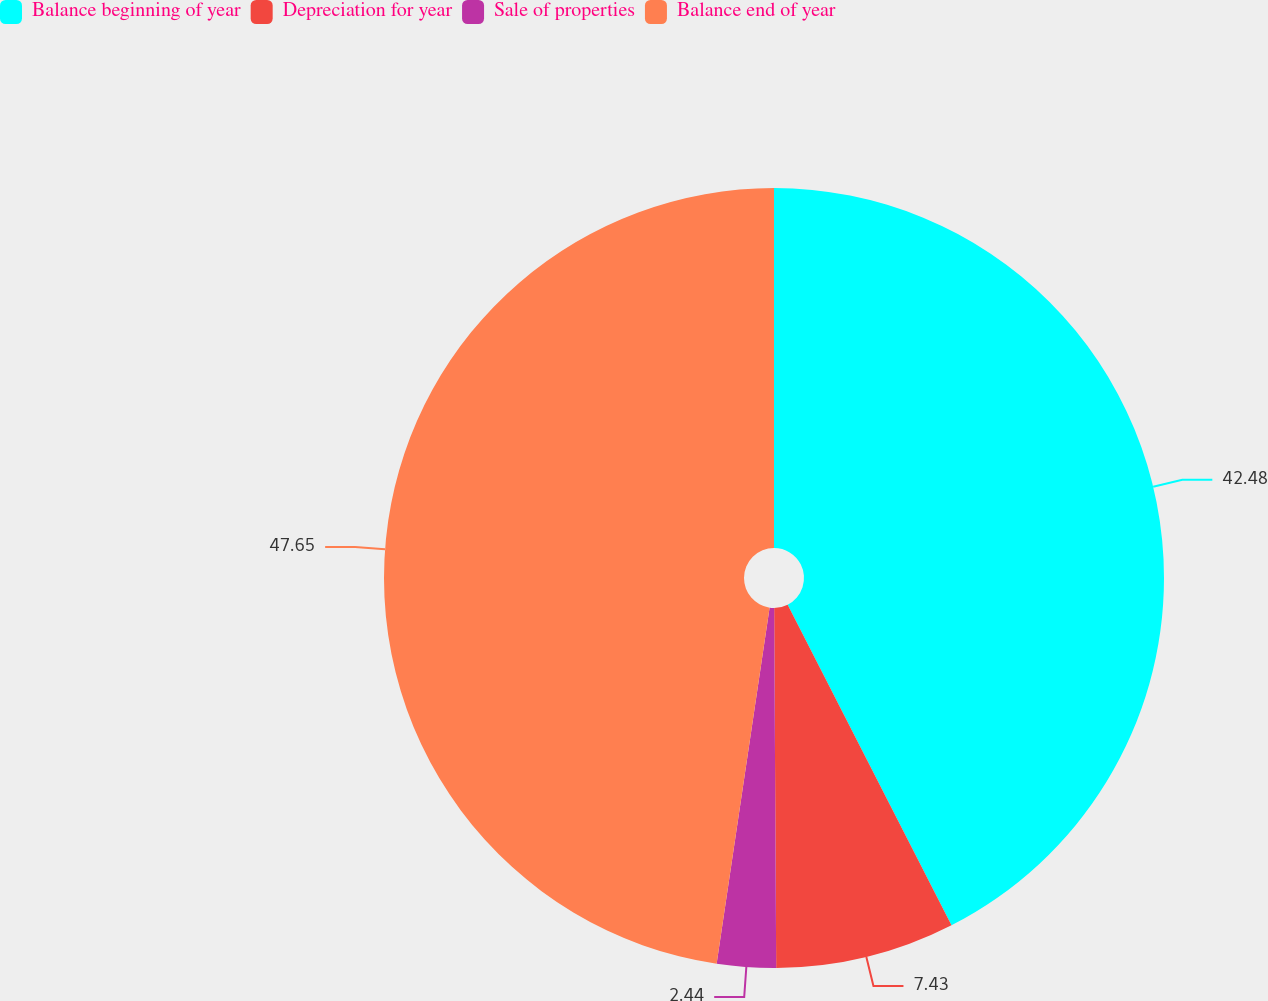Convert chart to OTSL. <chart><loc_0><loc_0><loc_500><loc_500><pie_chart><fcel>Balance beginning of year<fcel>Depreciation for year<fcel>Sale of properties<fcel>Balance end of year<nl><fcel>42.48%<fcel>7.43%<fcel>2.44%<fcel>47.65%<nl></chart> 